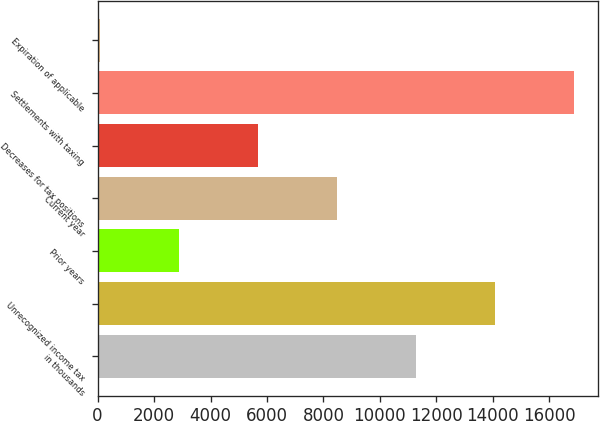Convert chart. <chart><loc_0><loc_0><loc_500><loc_500><bar_chart><fcel>in thousands<fcel>Unrecognized income tax<fcel>Prior years<fcel>Current year<fcel>Decreases for tax positions<fcel>Settlements with taxing<fcel>Expiration of applicable<nl><fcel>11275.6<fcel>14075.5<fcel>2875.9<fcel>8475.7<fcel>5675.8<fcel>16875.4<fcel>76<nl></chart> 